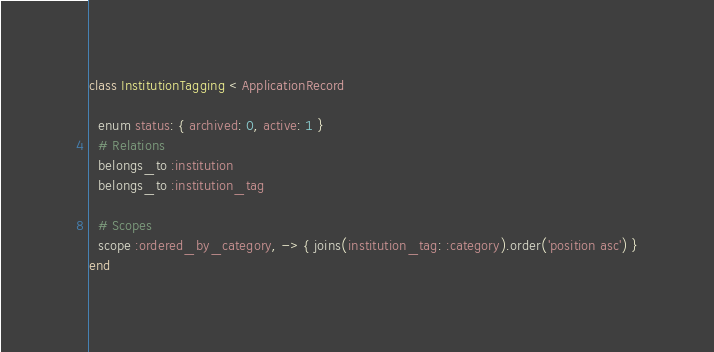<code> <loc_0><loc_0><loc_500><loc_500><_Ruby_>class InstitutionTagging < ApplicationRecord

  enum status: { archived: 0, active: 1 }
  # Relations
  belongs_to :institution
  belongs_to :institution_tag

  # Scopes
  scope :ordered_by_category, -> { joins(institution_tag: :category).order('position asc') }
end
</code> 